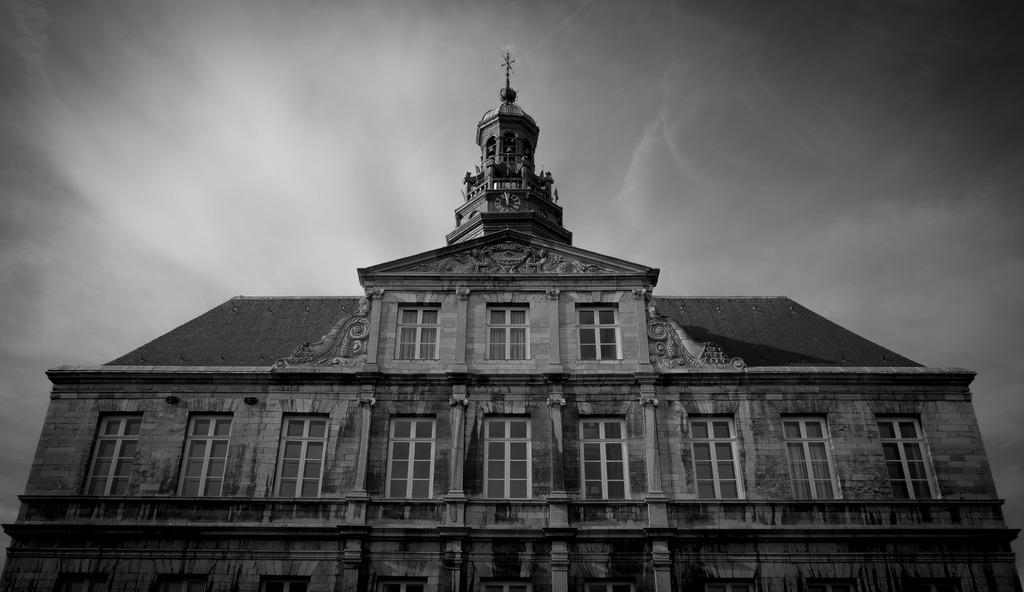What is the color scheme of the image? The image is black and white. What is the main subject of the image? There is a building in the image. Are there any additional features on the building? Yes, there are statues on top of the building. What can be seen in the background of the image? The sky is visible in the background of the image. What is the condition of the sky in the image? There are clouds in the sky. Can you tell me how many yaks are grazing in front of the building in the image? There are no yaks present in the image; it features a building with statues and a cloudy sky. What type of mine is visible in the image? There is no mine present in the image; it is a black and white photograph of a building with statues and a cloudy sky. 